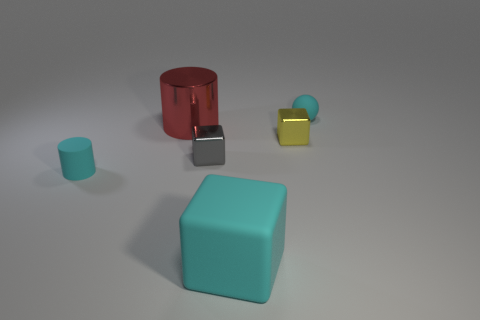Add 1 matte cylinders. How many objects exist? 7 Subtract all cylinders. How many objects are left? 4 Add 5 tiny green rubber things. How many tiny green rubber things exist? 5 Subtract 0 green blocks. How many objects are left? 6 Subtract all cyan rubber cylinders. Subtract all tiny blue metal cylinders. How many objects are left? 5 Add 1 large cylinders. How many large cylinders are left? 2 